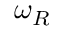Convert formula to latex. <formula><loc_0><loc_0><loc_500><loc_500>\omega _ { R }</formula> 